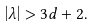Convert formula to latex. <formula><loc_0><loc_0><loc_500><loc_500>\left | \lambda \right | > 3 d + 2 .</formula> 